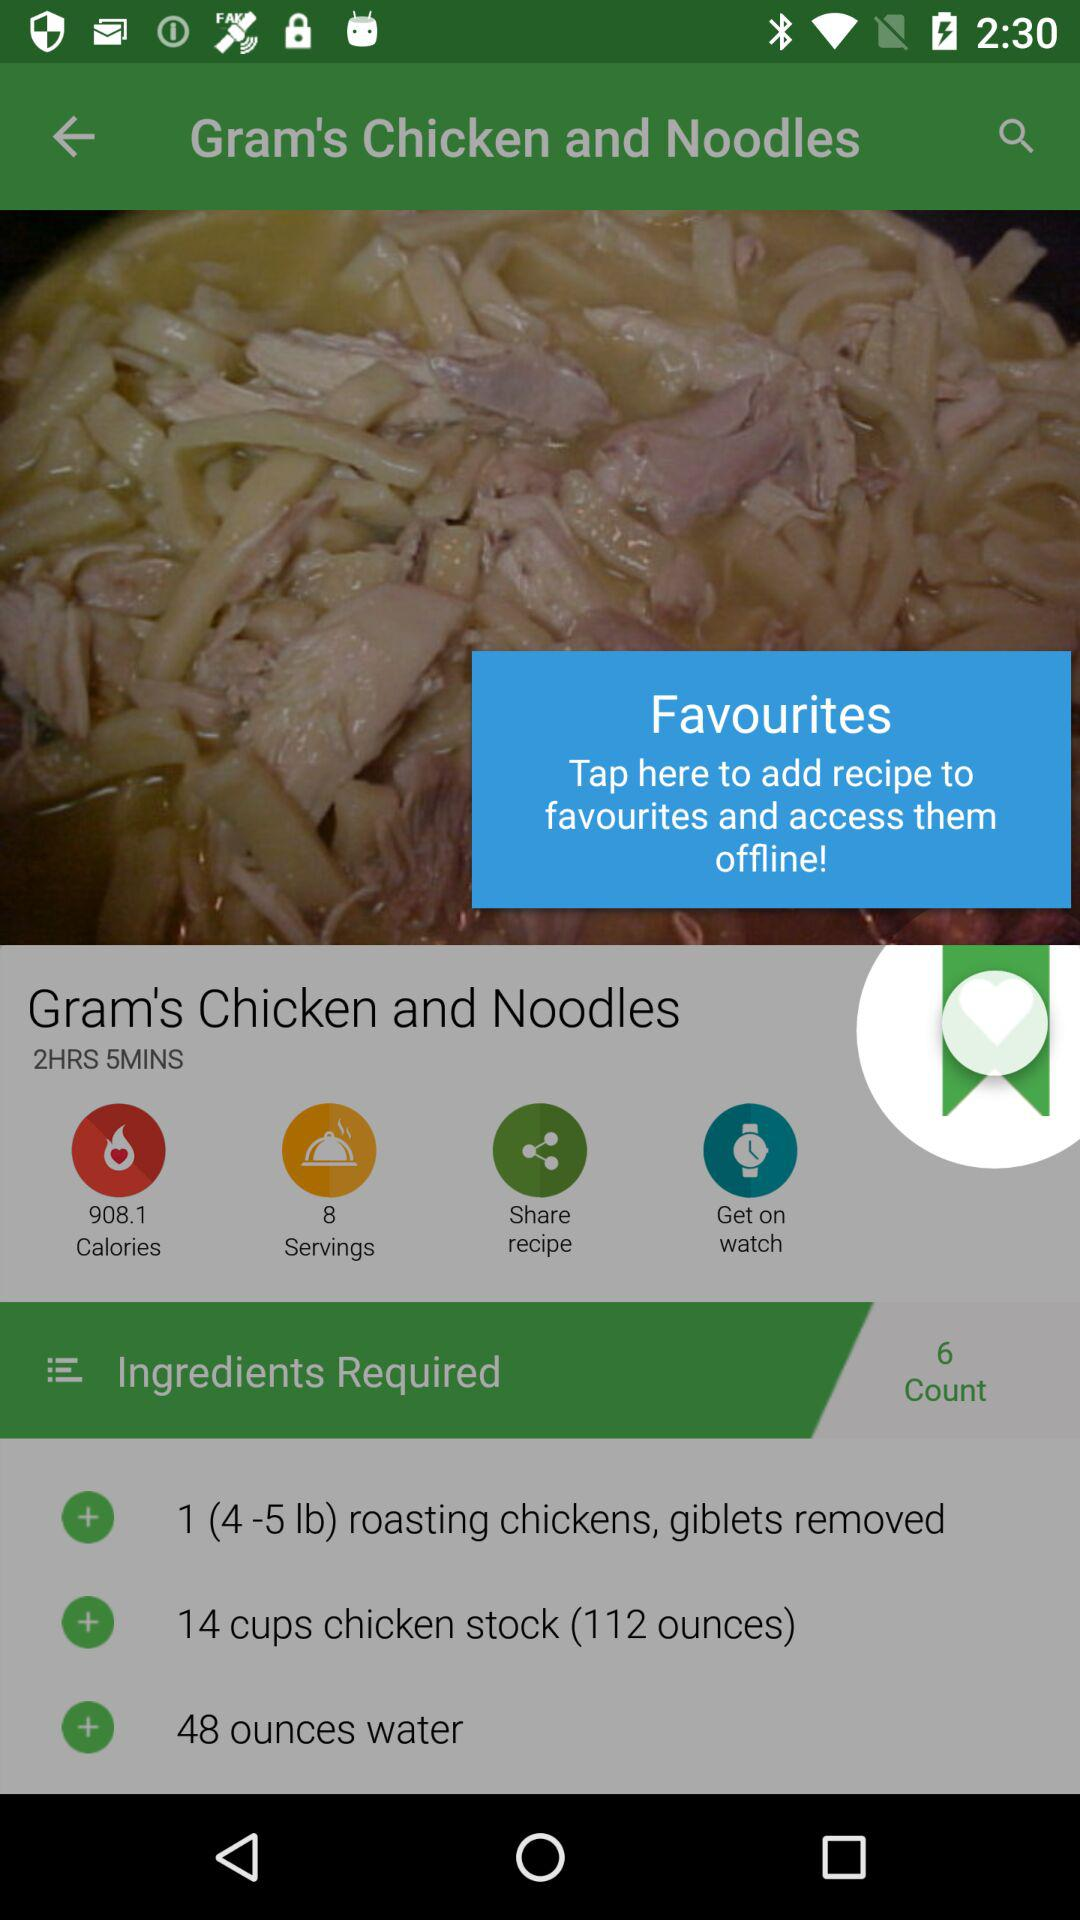How many ounces of water are needed to make the recipe? There are 48 ounces of water needed to make the recipe. 